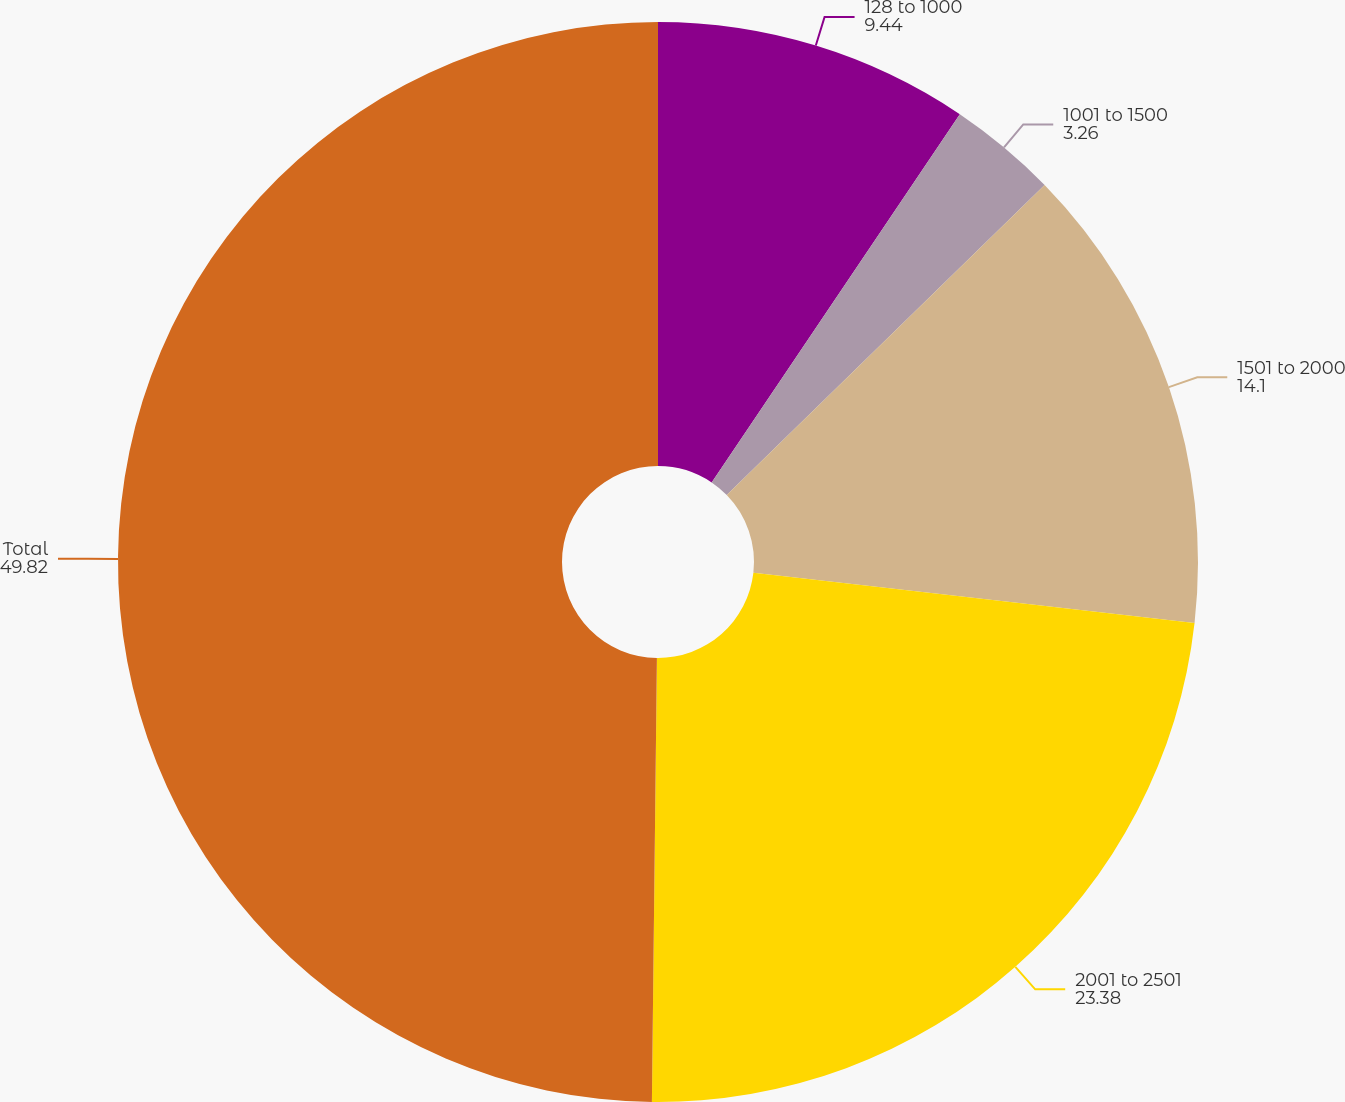Convert chart. <chart><loc_0><loc_0><loc_500><loc_500><pie_chart><fcel>128 to 1000<fcel>1001 to 1500<fcel>1501 to 2000<fcel>2001 to 2501<fcel>Total<nl><fcel>9.44%<fcel>3.26%<fcel>14.1%<fcel>23.38%<fcel>49.82%<nl></chart> 